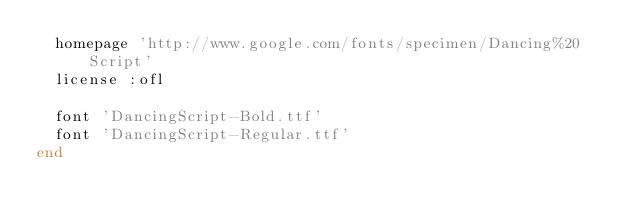Convert code to text. <code><loc_0><loc_0><loc_500><loc_500><_Ruby_>  homepage 'http://www.google.com/fonts/specimen/Dancing%20Script'
  license :ofl

  font 'DancingScript-Bold.ttf'
  font 'DancingScript-Regular.ttf'
end
</code> 